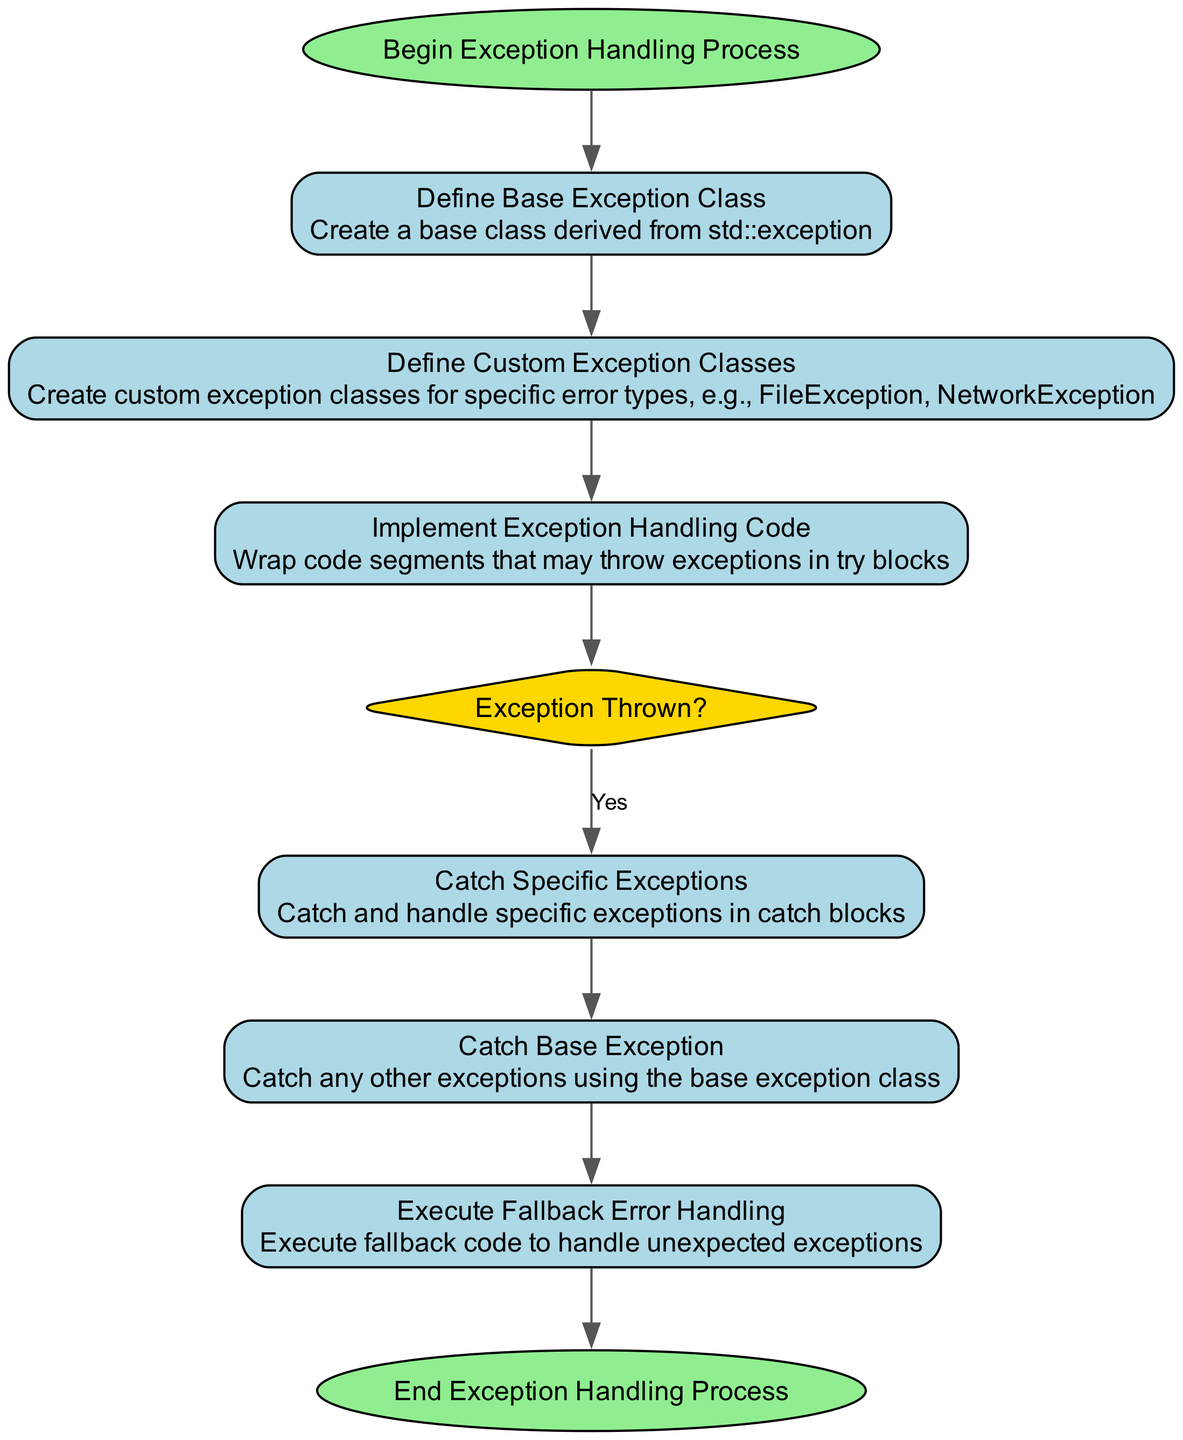What is the first action in the diagram? The diagram starts with the node labeled "Begin Exception Handling Process," which indicates the initiation of the exception handling process. Thus, the first action is the one following it in the flow, which states "Define Base Exception Class."
Answer: Define Base Exception Class How many action nodes are present in the diagram? Counting the action nodes, we find five specific actions that are included: "Define Base Exception Class," "Define Custom Exception Classes," "Implement Exception Handling Code," "Catch Specific Exceptions," and "Catch Base Exception." Therefore, the total is five action nodes.
Answer: Five What decision node is present in the diagram? The decision node in the diagram is labeled "Exception Thrown?". It evaluates whether an exception has occurred during the execution of the code. This is crucial for determining the flow for exception handling.
Answer: Exception Thrown? What happens if an exception is thrown? If an exception is thrown, the flow follows the path labeled "Yes" from the decision node "Exception Thrown?" to the action node "Catch Specific Exceptions," which signifies that the program will attempt to catch specific exceptions.
Answer: Catch Specific Exceptions What is the final action before the process ends? The last action in the flow before reaching the end of the process is "Execute Fallback Error Handling." This action indicates that the program executes a fallback mechanism to handle any unexpected exceptions.
Answer: Execute Fallback Error Handling How many total nodes are in the diagram? There are ten nodes in total, which include one start node, one end node, one decision node, and seven action nodes. The combination of these nodes accounts for the whole structure of the diagram.
Answer: Ten What type of node contains exceptions handling code? The action node labeled "Implement Exception Handling Code" specifically refers to wrapping code segments that may throw exceptions inside try blocks. This indicates where the exception handling is actually implemented.
Answer: Implement Exception Handling Code What is the relationship between "Catch Base Exception" and "Catch Specific Exceptions"? Both action nodes are connected sequentially following the decision "Exception Thrown?". If a specific exception is not caught, the flow progresses to "Catch Base Exception," which handles any other exceptions. This shows a protective hierarchy in the handling process.
Answer: Sequential actions What label is associated with the edge leading from the decision node when an exception is not thrown? The label corresponding to the edge leading from the decision node "Exception Thrown?" when an exception is not thrown would be "No." This indicates the direct flow when there is no exception.
Answer: No 